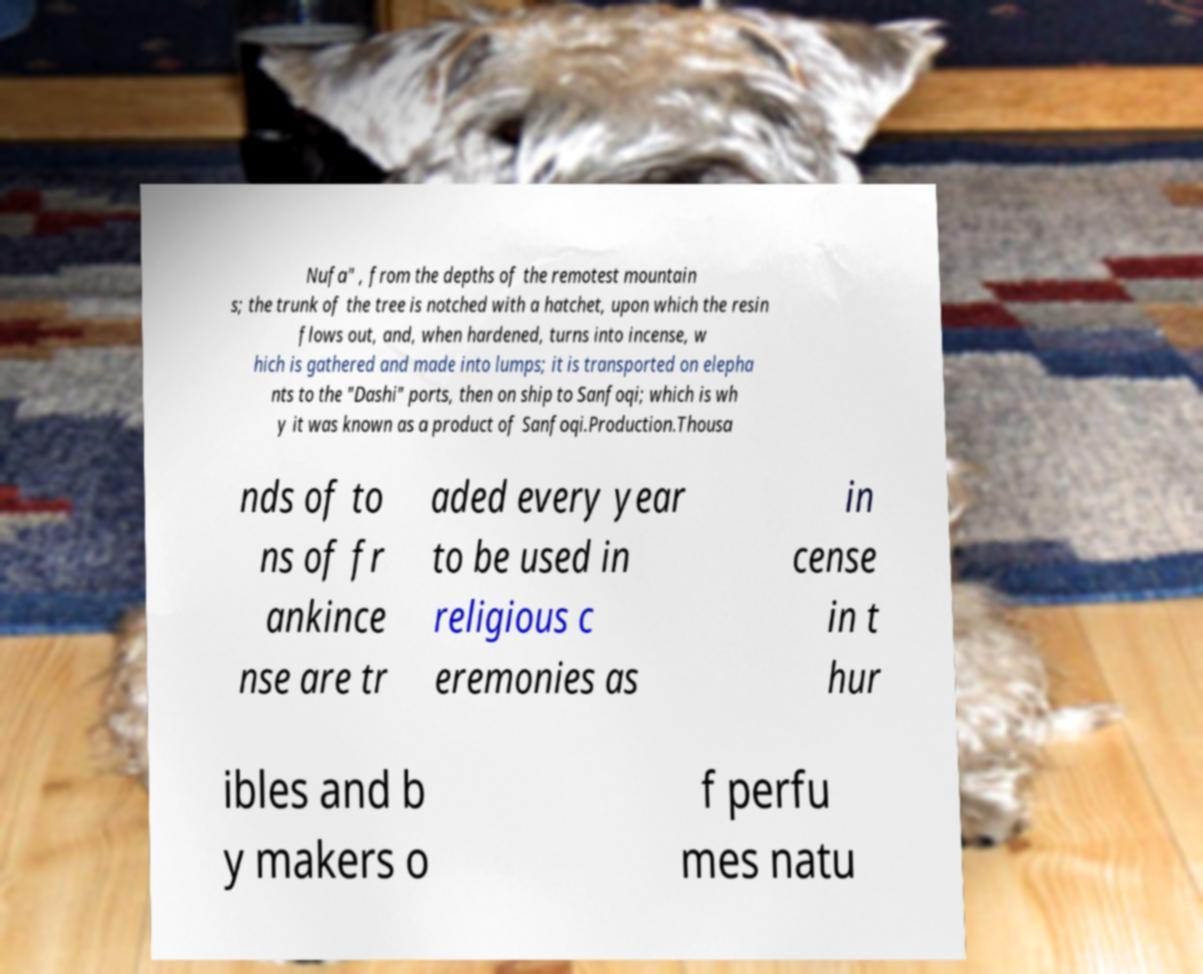Could you assist in decoding the text presented in this image and type it out clearly? Nufa" , from the depths of the remotest mountain s; the trunk of the tree is notched with a hatchet, upon which the resin flows out, and, when hardened, turns into incense, w hich is gathered and made into lumps; it is transported on elepha nts to the "Dashi" ports, then on ship to Sanfoqi; which is wh y it was known as a product of Sanfoqi.Production.Thousa nds of to ns of fr ankince nse are tr aded every year to be used in religious c eremonies as in cense in t hur ibles and b y makers o f perfu mes natu 